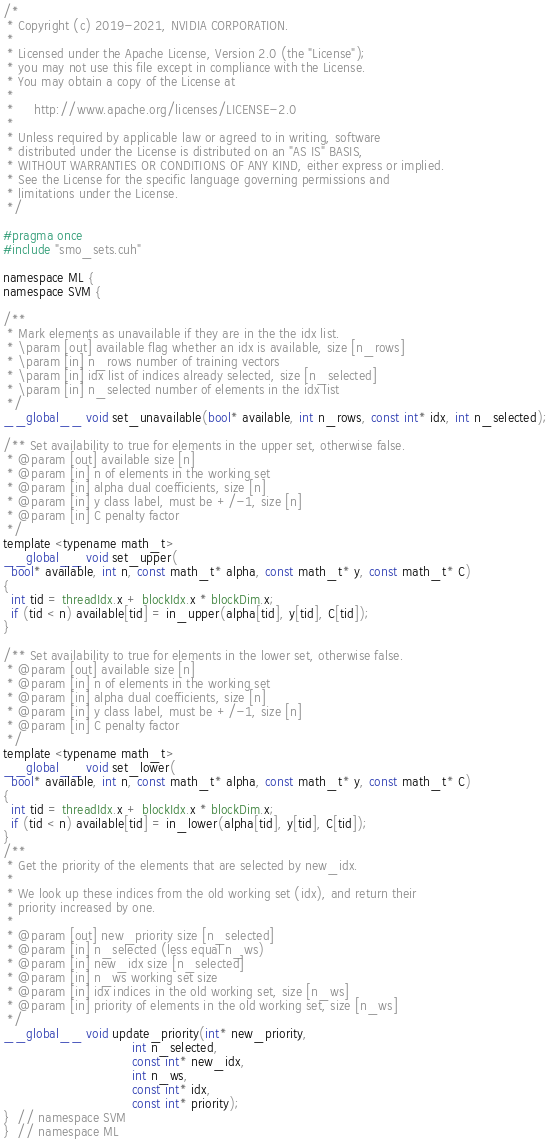<code> <loc_0><loc_0><loc_500><loc_500><_Cuda_>/*
 * Copyright (c) 2019-2021, NVIDIA CORPORATION.
 *
 * Licensed under the Apache License, Version 2.0 (the "License");
 * you may not use this file except in compliance with the License.
 * You may obtain a copy of the License at
 *
 *     http://www.apache.org/licenses/LICENSE-2.0
 *
 * Unless required by applicable law or agreed to in writing, software
 * distributed under the License is distributed on an "AS IS" BASIS,
 * WITHOUT WARRANTIES OR CONDITIONS OF ANY KIND, either express or implied.
 * See the License for the specific language governing permissions and
 * limitations under the License.
 */

#pragma once
#include "smo_sets.cuh"

namespace ML {
namespace SVM {

/**
 * Mark elements as unavailable if they are in the the idx list.
 * \param [out] available flag whether an idx is available, size [n_rows]
 * \param [in] n_rows number of training vectors
 * \param [in] idx list of indices already selected, size [n_selected]
 * \param [in] n_selected number of elements in the idx list
 */
__global__ void set_unavailable(bool* available, int n_rows, const int* idx, int n_selected);

/** Set availability to true for elements in the upper set, otherwise false.
 * @param [out] available size [n]
 * @param [in] n of elements in the working set
 * @param [in] alpha dual coefficients, size [n]
 * @param [in] y class label, must be +/-1, size [n]
 * @param [in] C penalty factor
 */
template <typename math_t>
__global__ void set_upper(
  bool* available, int n, const math_t* alpha, const math_t* y, const math_t* C)
{
  int tid = threadIdx.x + blockIdx.x * blockDim.x;
  if (tid < n) available[tid] = in_upper(alpha[tid], y[tid], C[tid]);
}

/** Set availability to true for elements in the lower set, otherwise false.
 * @param [out] available size [n]
 * @param [in] n of elements in the working set
 * @param [in] alpha dual coefficients, size [n]
 * @param [in] y class label, must be +/-1, size [n]
 * @param [in] C penalty factor
 */
template <typename math_t>
__global__ void set_lower(
  bool* available, int n, const math_t* alpha, const math_t* y, const math_t* C)
{
  int tid = threadIdx.x + blockIdx.x * blockDim.x;
  if (tid < n) available[tid] = in_lower(alpha[tid], y[tid], C[tid]);
}
/**
 * Get the priority of the elements that are selected by new_idx.
 *
 * We look up these indices from the old working set (idx), and return their
 * priority increased by one.
 *
 * @param [out] new_priority size [n_selected]
 * @param [in] n_selected (less equal n_ws)
 * @param [in] new_idx size [n_selected]
 * @param [in] n_ws working set size
 * @param [in] idx indices in the old working set, size [n_ws]
 * @param [in] priority of elements in the old working set, size [n_ws]
 */
__global__ void update_priority(int* new_priority,
                                int n_selected,
                                const int* new_idx,
                                int n_ws,
                                const int* idx,
                                const int* priority);
}  // namespace SVM
}  // namespace ML
</code> 